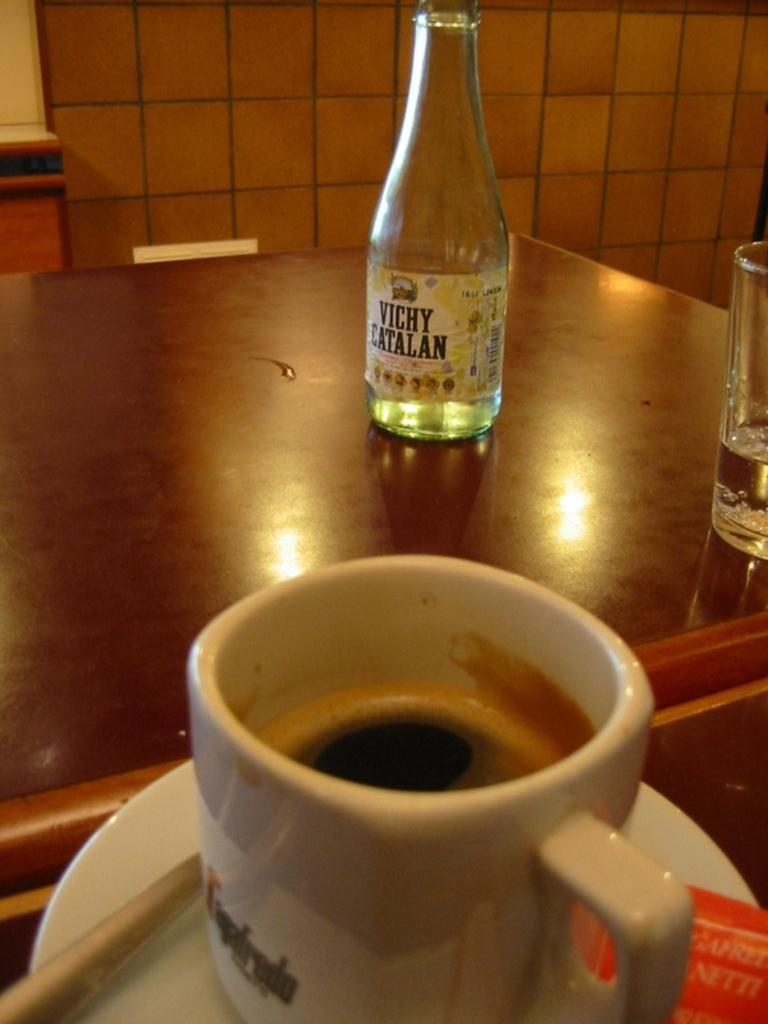<image>
Describe the image concisely. a cup of coffee, a water glass, and a bottle that says Vichy Catalan on it sitting on a table. 